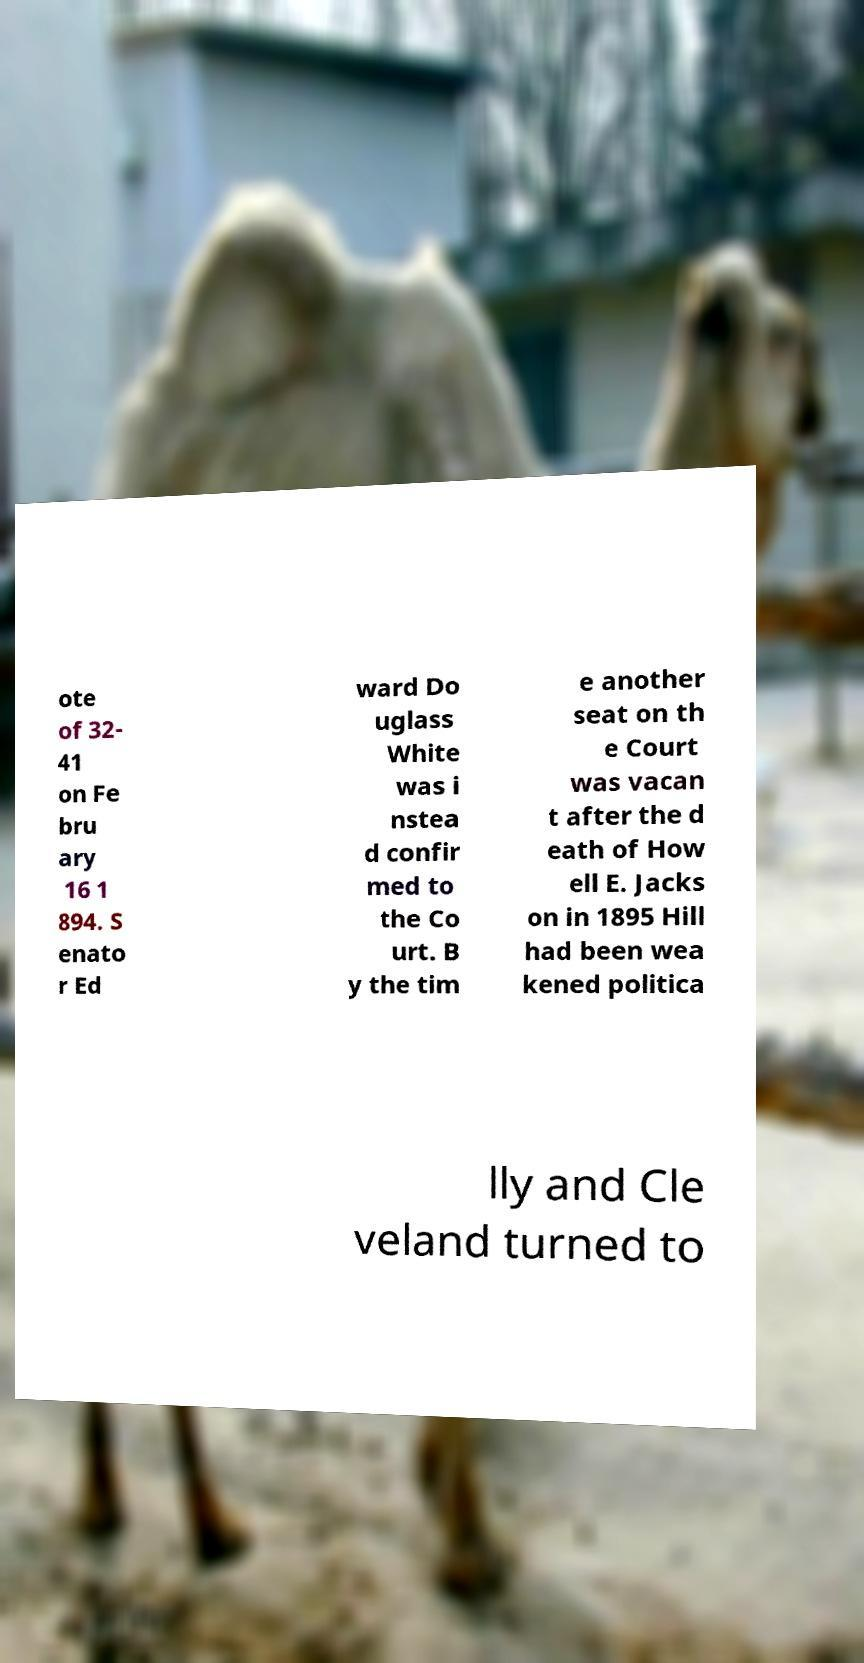There's text embedded in this image that I need extracted. Can you transcribe it verbatim? ote of 32- 41 on Fe bru ary 16 1 894. S enato r Ed ward Do uglass White was i nstea d confir med to the Co urt. B y the tim e another seat on th e Court was vacan t after the d eath of How ell E. Jacks on in 1895 Hill had been wea kened politica lly and Cle veland turned to 